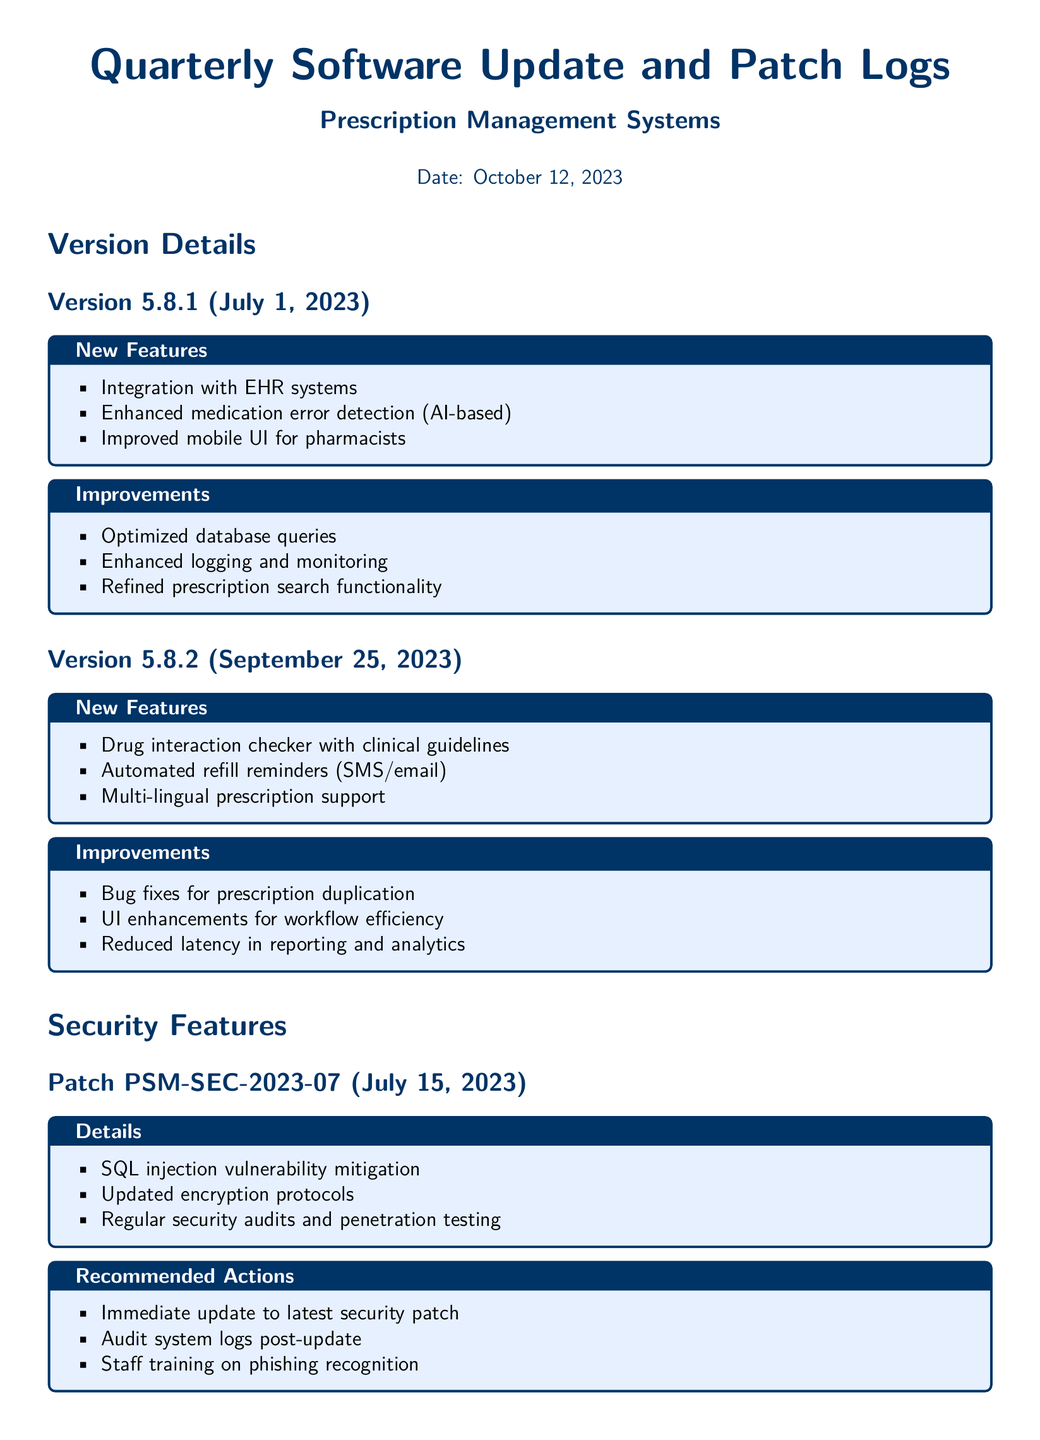What is the date of the document? The date of the document is specified at the top, which is October 12, 2023.
Answer: October 12, 2023 What version was released on September 25, 2023? The version released on September 25, 2023, is 5.8.2.
Answer: 5.8.2 Which new feature was added in version 5.8.2? The new features added in version 5.8.2 include a drug interaction checker with clinical guidelines.
Answer: Drug interaction checker with clinical guidelines What security patch was issued on July 15, 2023? The security patch issued on July 15, 2023, is PSM-SEC-2023-07.
Answer: PSM-SEC-2023-07 What is one recommended action for patch PSM-SEC-2023-09? One recommended action for patch PSM-SEC-2023-09 is to enable multi-factor authentication (MFA).
Answer: Enable multi-factor authentication (MFA) What feature improves medication error detection? The feature that improves medication error detection is AI-based enhancement.
Answer: AI-based enhancement What is the primary focus of the new features in version 5.8.1? The primary focus of the new features in version 5.8.1 is integration with EHR systems.
Answer: Integration with EHR systems What functionality did version 5.8.2 enhance? Version 5.8.2 enhanced UI for workflow efficiency.
Answer: UI for workflow efficiency 